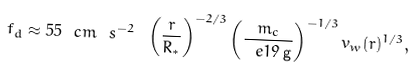Convert formula to latex. <formula><loc_0><loc_0><loc_500><loc_500>f _ { d } \approx 5 5 \ c m \ s ^ { - 2 } \ \left ( \frac { r } { R _ { * } } \right ) ^ { - 2 / 3 } \left ( \frac { m _ { c } } { \ e { 1 9 } \, { \mathrm g } } \right ) ^ { - 1 / 3 } v _ { w } ( r ) ^ { 1 / 3 } ,</formula> 